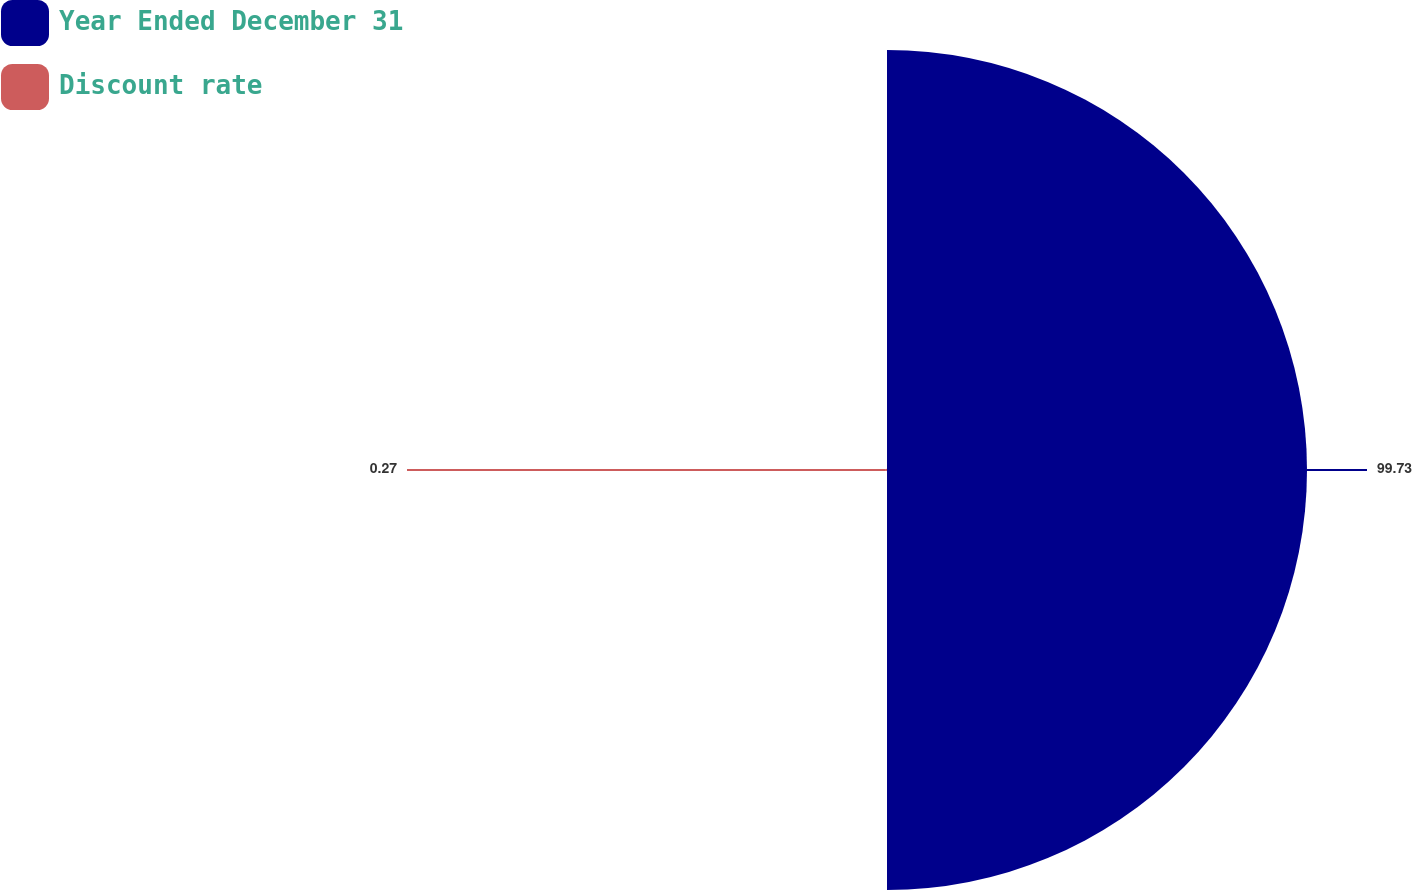Convert chart. <chart><loc_0><loc_0><loc_500><loc_500><pie_chart><fcel>Year Ended December 31<fcel>Discount rate<nl><fcel>99.73%<fcel>0.27%<nl></chart> 